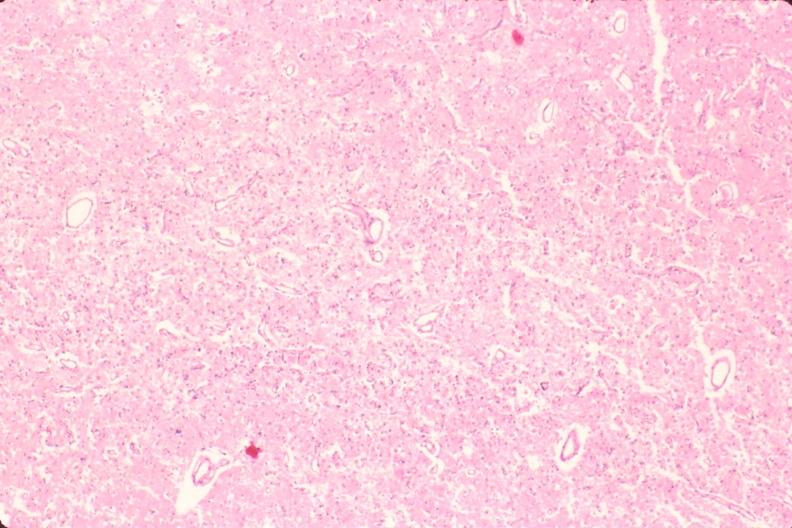what is present?
Answer the question using a single word or phrase. Nervous 